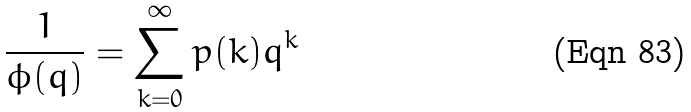<formula> <loc_0><loc_0><loc_500><loc_500>\frac { 1 } { \phi ( q ) } = \sum _ { k = 0 } ^ { \infty } p ( k ) q ^ { k }</formula> 